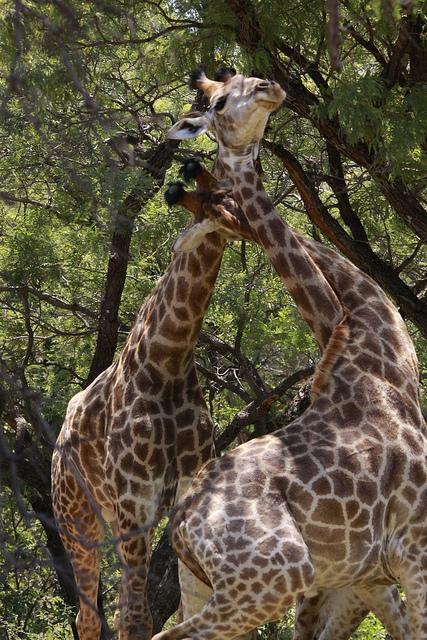How many Giraffes are in this image?
Give a very brief answer. 2. How many giraffes are in the picture?
Give a very brief answer. 2. How many dogs are in this picture?
Give a very brief answer. 0. 